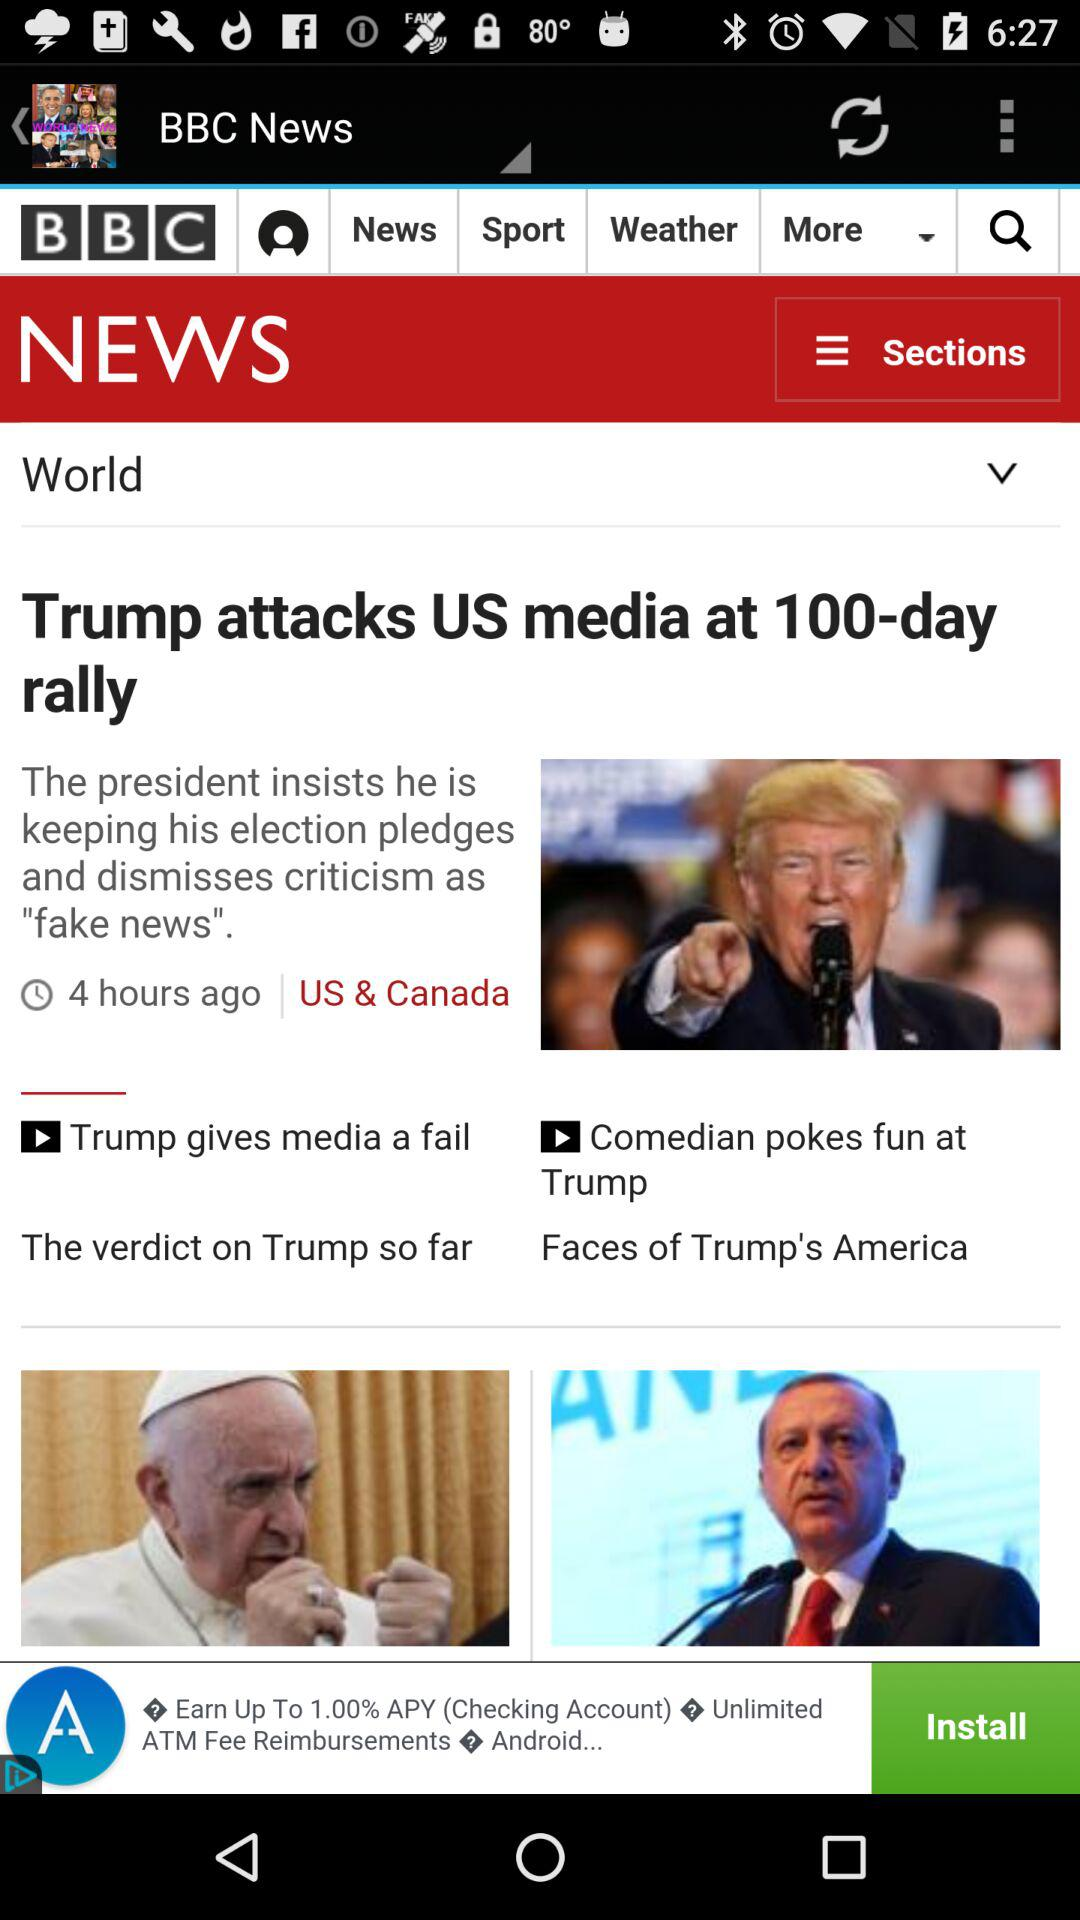When was the news that "Trump attacks US media at 100-day rally" published? The news was published 4 hours ago. 